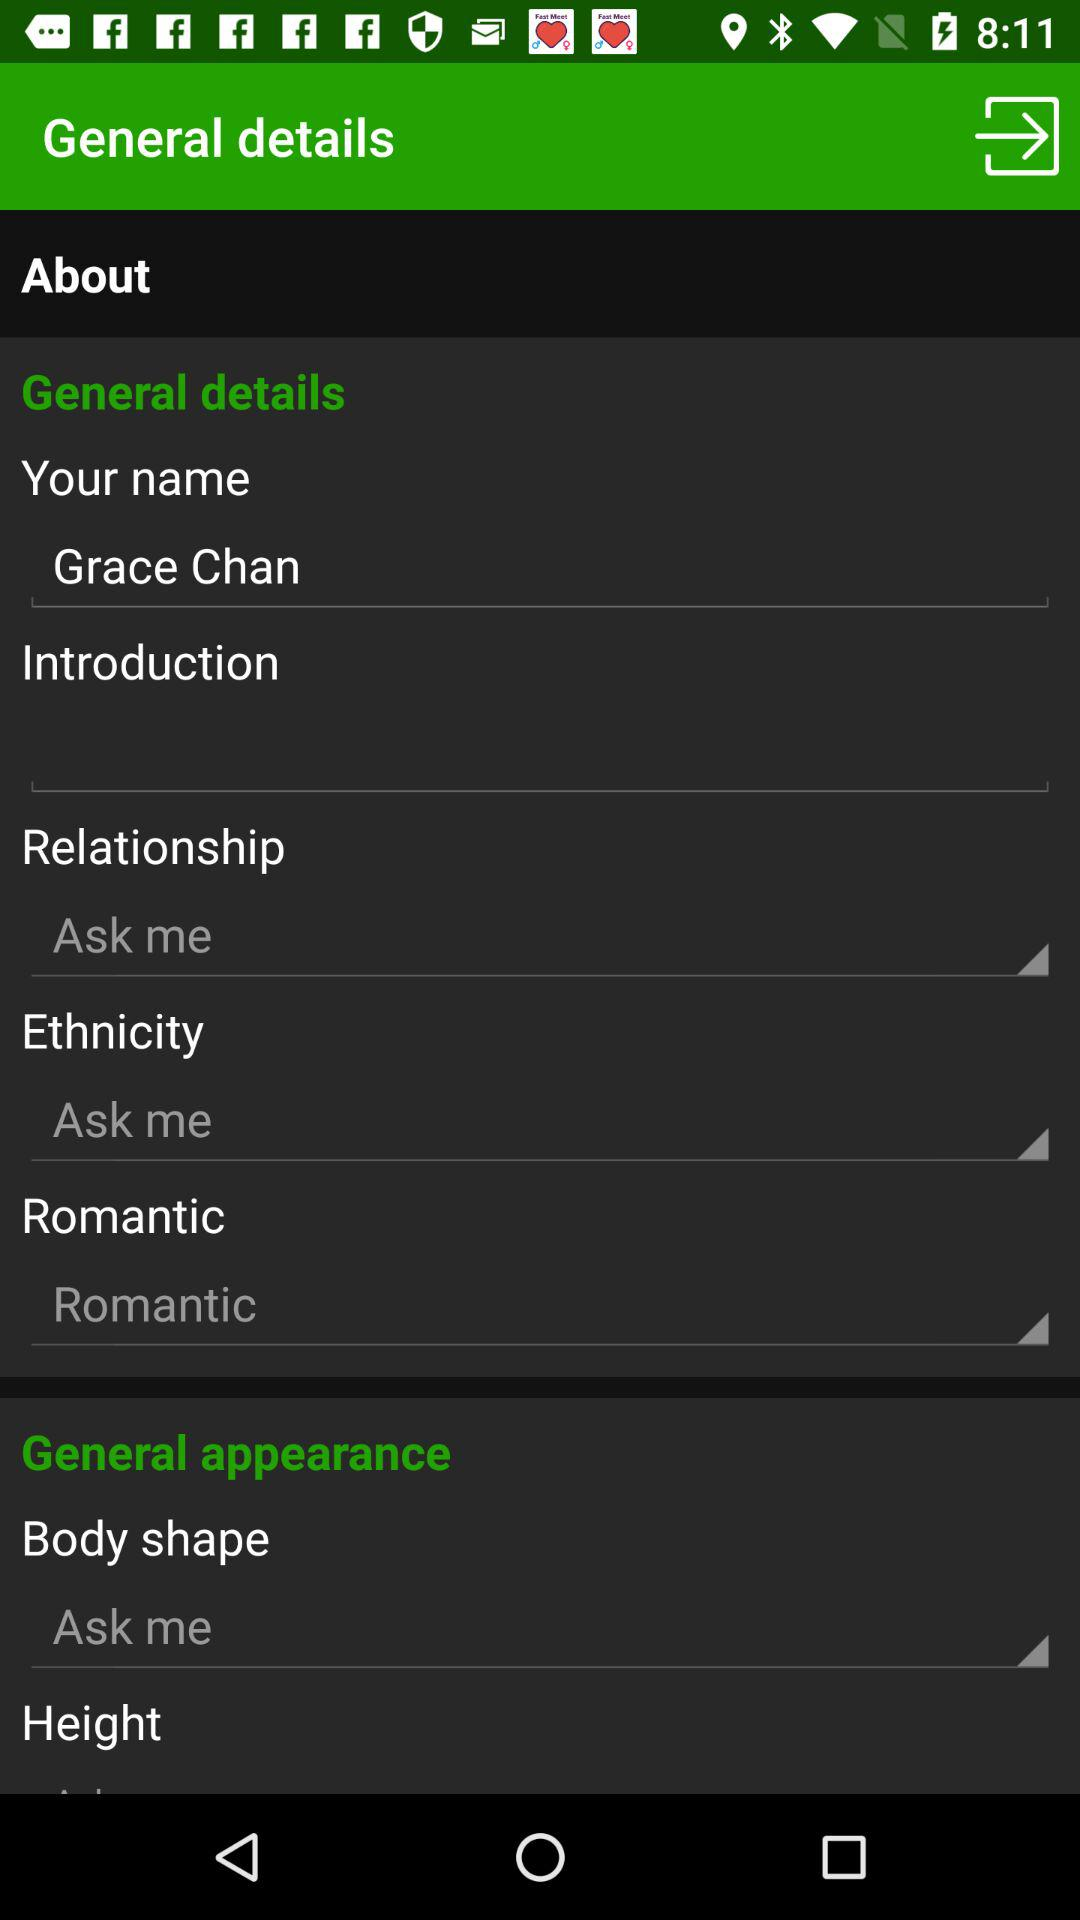What is the name? The name is Grace Chan. 